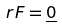<formula> <loc_0><loc_0><loc_500><loc_500>r F = \underline { 0 }</formula> 